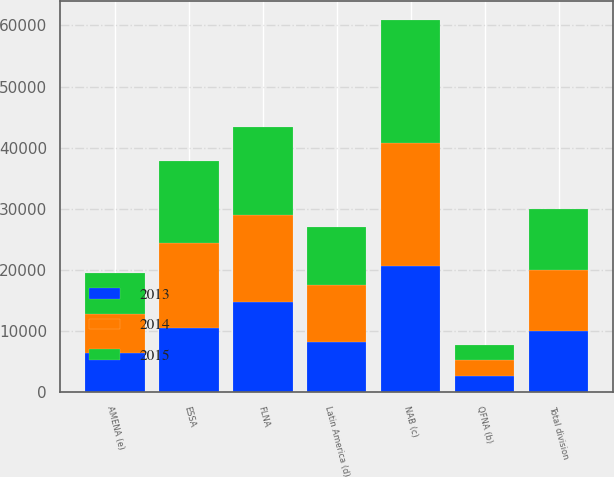<chart> <loc_0><loc_0><loc_500><loc_500><stacked_bar_chart><ecel><fcel>FLNA<fcel>QFNA (b)<fcel>NAB (c)<fcel>Latin America (d)<fcel>ESSA<fcel>AMENA (e)<fcel>Total division<nl><fcel>2013<fcel>14782<fcel>2543<fcel>20618<fcel>8228<fcel>10510<fcel>6375<fcel>9967.5<nl><fcel>2015<fcel>14502<fcel>2568<fcel>20171<fcel>9425<fcel>13399<fcel>6618<fcel>9967.5<nl><fcel>2014<fcel>14126<fcel>2612<fcel>20083<fcel>9335<fcel>13828<fcel>6431<fcel>9967.5<nl></chart> 